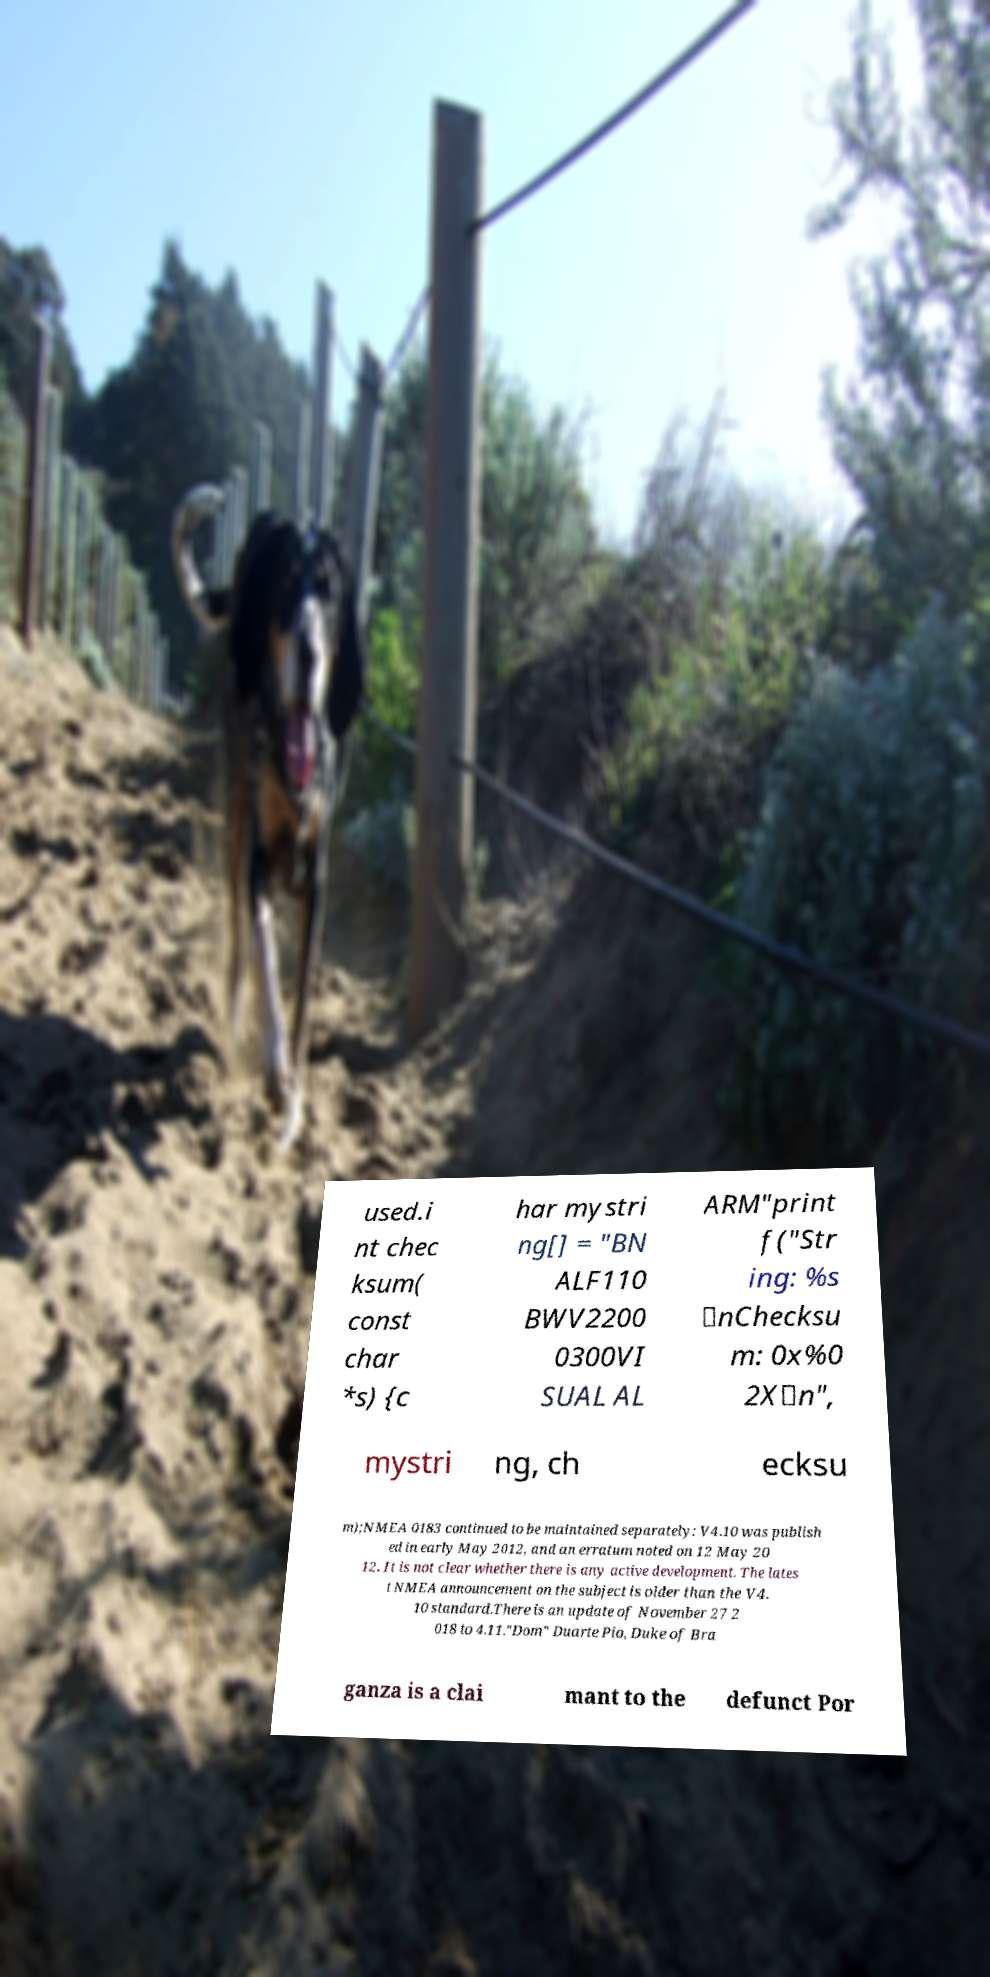I need the written content from this picture converted into text. Can you do that? used.i nt chec ksum( const char *s) {c har mystri ng[] = "BN ALF110 BWV2200 0300VI SUAL AL ARM"print f("Str ing: %s \nChecksu m: 0x%0 2X\n", mystri ng, ch ecksu m);NMEA 0183 continued to be maintained separately: V4.10 was publish ed in early May 2012, and an erratum noted on 12 May 20 12. It is not clear whether there is any active development. The lates t NMEA announcement on the subject is older than the V4. 10 standard.There is an update of November 27 2 018 to 4.11."Dom" Duarte Pio, Duke of Bra ganza is a clai mant to the defunct Por 